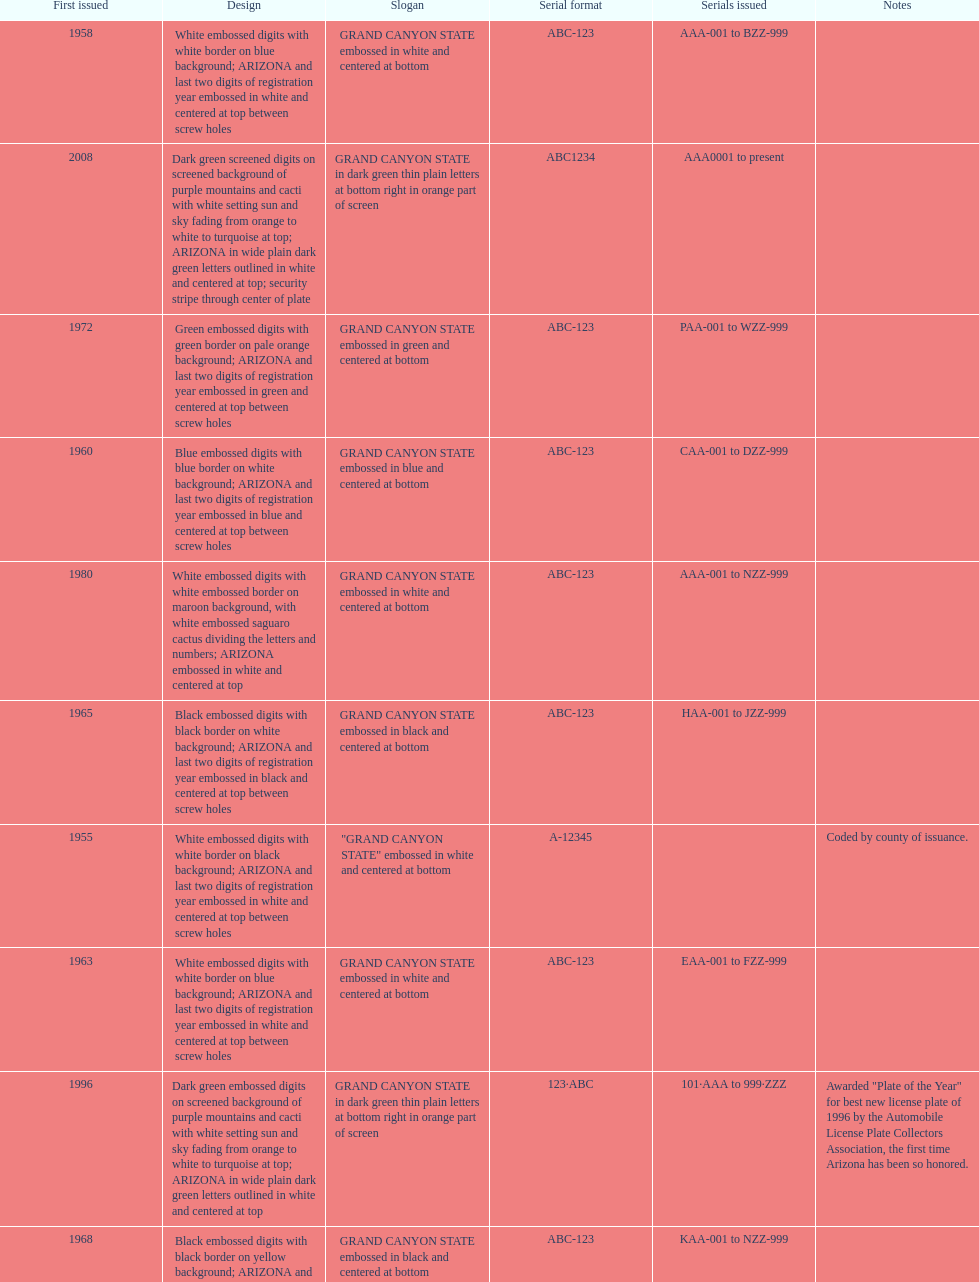Name the year of the license plate that has the largest amount of alphanumeric digits. 2008. 